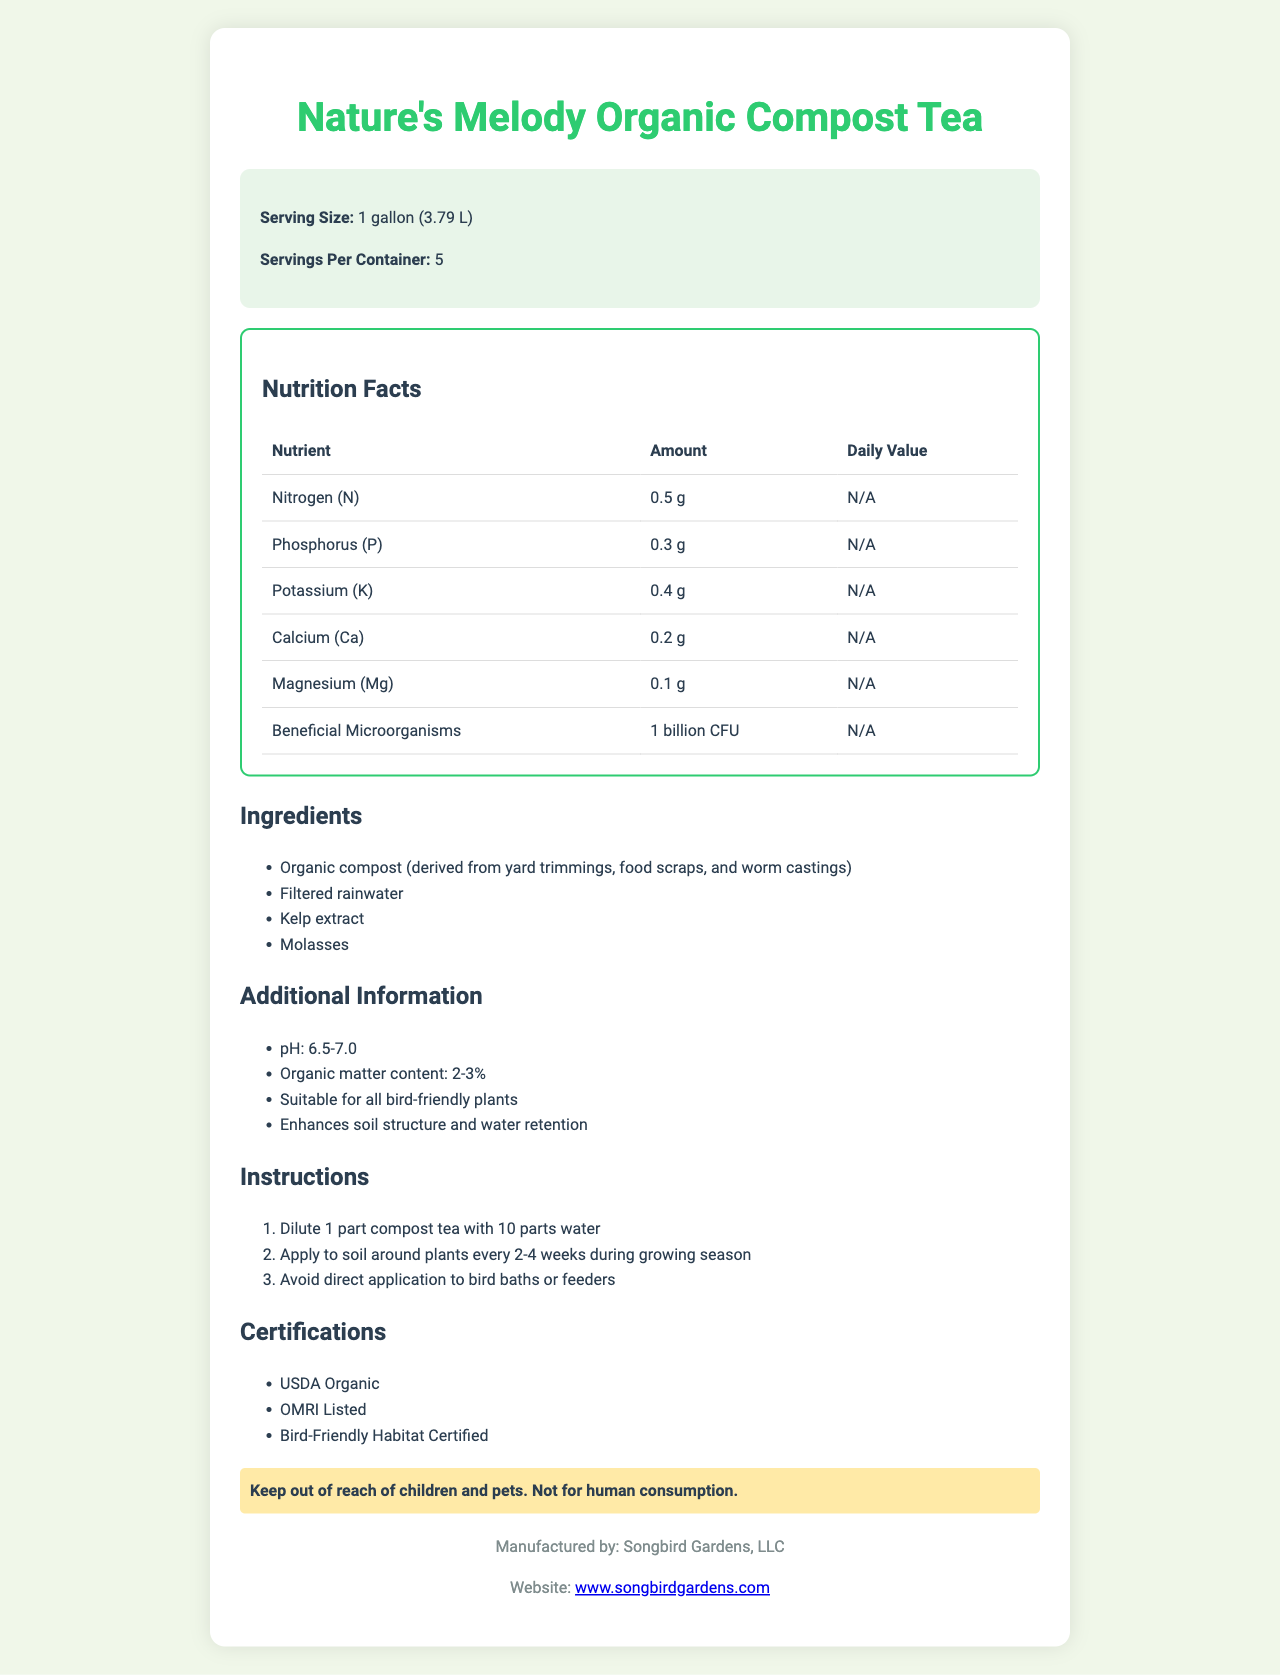what is the product name? The product name is prominently displayed at the top of the document.
Answer: Nature's Melody Organic Compost Tea what is the serving size for this compost tea? The serving size information is located in the product info section near the top of the document.
Answer: 1 gallon (3.79 L) how many servings are there per container? The number of servings per container is listed in the product info section near the top of the document.
Answer: 5 what is the pH range of this product? The pH range is provided in the additional information section of the document.
Answer: 6.5-7.0 what certifications does this product have? The certifications are listed clearly in the certifications section of the document.
Answer: USDA Organic, OMRI Listed, Bird-Friendly Habitat Certified which one of these is an ingredient in the compost tea? A. Fish emulsion B. Bone meal C. Kelp extract The ingredients section lists kelp extract as one of the ingredients in the compost tea.
Answer: C. Kelp extract how often should the compost tea be applied during the growing season? A. Every 1-2 weeks B. Every 2-4 weeks C. Every 4-6 weeks The instructions section specifies that the compost tea should be applied to soil around plants every 2-4 weeks during the growing season.
Answer: B. Every 2-4 weeks is this compost tea safe for direct application to bird baths or feeders? The instructions section includes advice to avoid direct application to bird baths or feeders, implying it is not safe for them.
Answer: No is the compost tea certified organic? The certifications section lists "USDA Organic" making it clear that the compost tea is certified organic.
Answer: Yes describe the main idea of the document. The document gives a comprehensive overview of the product, highlighting essential details like nutrient content, pH level, ingredients, application instructions, and its certifications, making it suitable for bird-friendly gardening.
Answer: The document provides detailed information about Nature's Melody Organic Compost Tea, including its serving size, nutrient content, ingredients, additional information, instructions for use, certifications, and warnings. It emphasizes its suitability for bird-friendly gardens and provides care guidelines for proper use. who is the manufacturer of the compost tea? The manufacturer information is located at the bottom of the document in the footer section.
Answer: Songbird Gardens, LLC what is the URL of the website for more information on the product? The website is listed in the footer section of the document.
Answer: www.songbirdgardens.com what is the price of Nature's Melody Organic Compost Tea? The document does not provide any information related to the price of the product.
Answer: Not enough information 